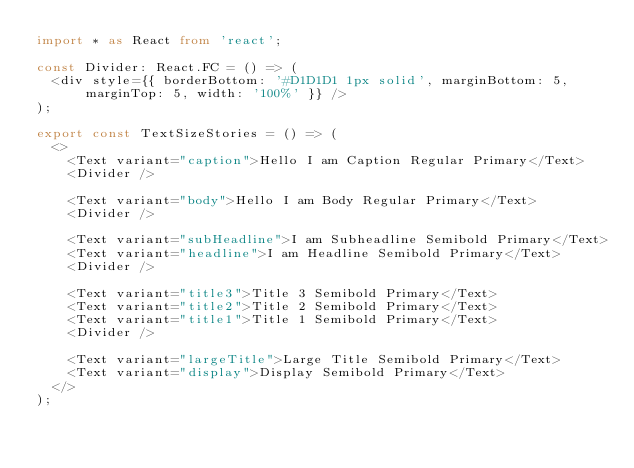Convert code to text. <code><loc_0><loc_0><loc_500><loc_500><_TypeScript_>import * as React from 'react';

const Divider: React.FC = () => (
  <div style={{ borderBottom: '#D1D1D1 1px solid', marginBottom: 5, marginTop: 5, width: '100%' }} />
);

export const TextSizeStories = () => (
  <>
    <Text variant="caption">Hello I am Caption Regular Primary</Text>
    <Divider />

    <Text variant="body">Hello I am Body Regular Primary</Text>
    <Divider />

    <Text variant="subHeadline">I am Subheadline Semibold Primary</Text>
    <Text variant="headline">I am Headline Semibold Primary</Text>
    <Divider />

    <Text variant="title3">Title 3 Semibold Primary</Text>
    <Text variant="title2">Title 2 Semibold Primary</Text>
    <Text variant="title1">Title 1 Semibold Primary</Text>
    <Divider />

    <Text variant="largeTitle">Large Title Semibold Primary</Text>
    <Text variant="display">Display Semibold Primary</Text>
  </>
);
</code> 